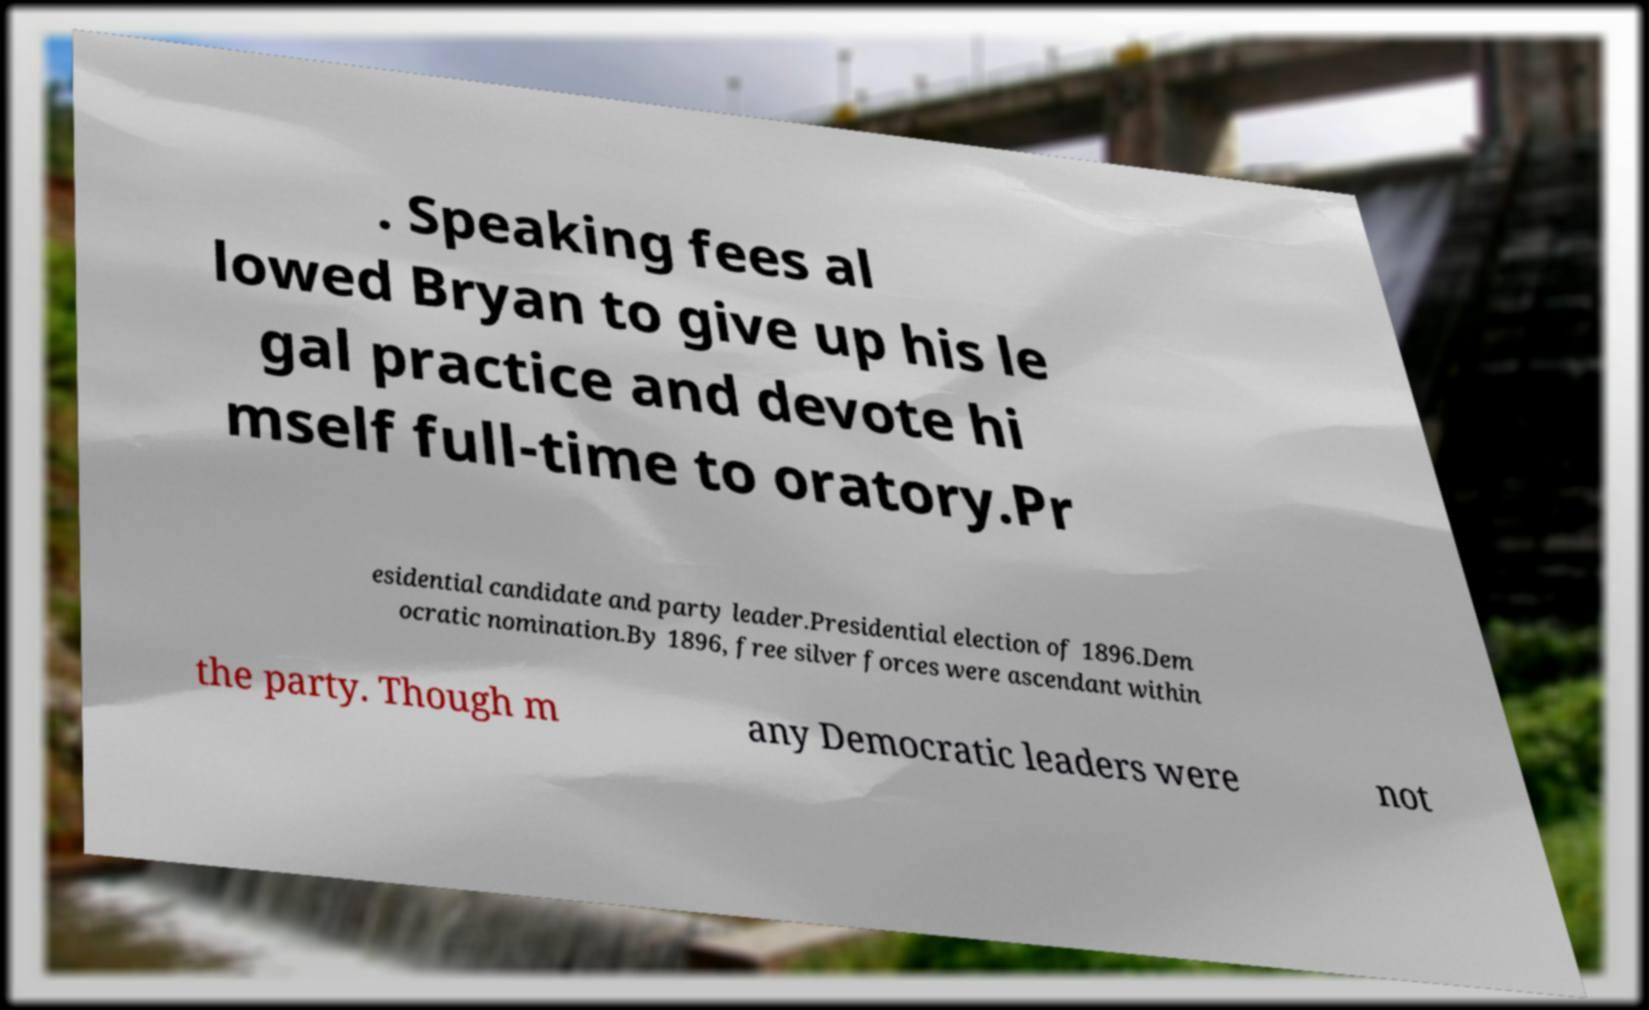Can you read and provide the text displayed in the image?This photo seems to have some interesting text. Can you extract and type it out for me? . Speaking fees al lowed Bryan to give up his le gal practice and devote hi mself full-time to oratory.Pr esidential candidate and party leader.Presidential election of 1896.Dem ocratic nomination.By 1896, free silver forces were ascendant within the party. Though m any Democratic leaders were not 